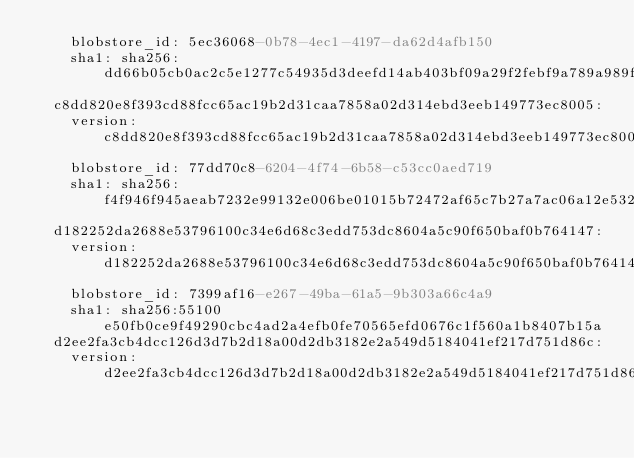<code> <loc_0><loc_0><loc_500><loc_500><_YAML_>    blobstore_id: 5ec36068-0b78-4ec1-4197-da62d4afb150
    sha1: sha256:dd66b05cb0ac2c5e1277c54935d3deefd14ab403bf09a29f2febf9a789a989f3
  c8dd820e8f393cd88fcc65ac19b2d31caa7858a02d314ebd3eeb149773ec8005:
    version: c8dd820e8f393cd88fcc65ac19b2d31caa7858a02d314ebd3eeb149773ec8005
    blobstore_id: 77dd70c8-6204-4f74-6b58-c53cc0aed719
    sha1: sha256:f4f946f945aeab7232e99132e006be01015b72472af65c7b27a7ac06a12e5327
  d182252da2688e53796100c34e6d68c3edd753dc8604a5c90f650baf0b764147:
    version: d182252da2688e53796100c34e6d68c3edd753dc8604a5c90f650baf0b764147
    blobstore_id: 7399af16-e267-49ba-61a5-9b303a66c4a9
    sha1: sha256:55100e50fb0ce9f49290cbc4ad2a4efb0fe70565efd0676c1f560a1b8407b15a
  d2ee2fa3cb4dcc126d3d7b2d18a00d2db3182e2a549d5184041ef217d751d86c:
    version: d2ee2fa3cb4dcc126d3d7b2d18a00d2db3182e2a549d5184041ef217d751d86c</code> 